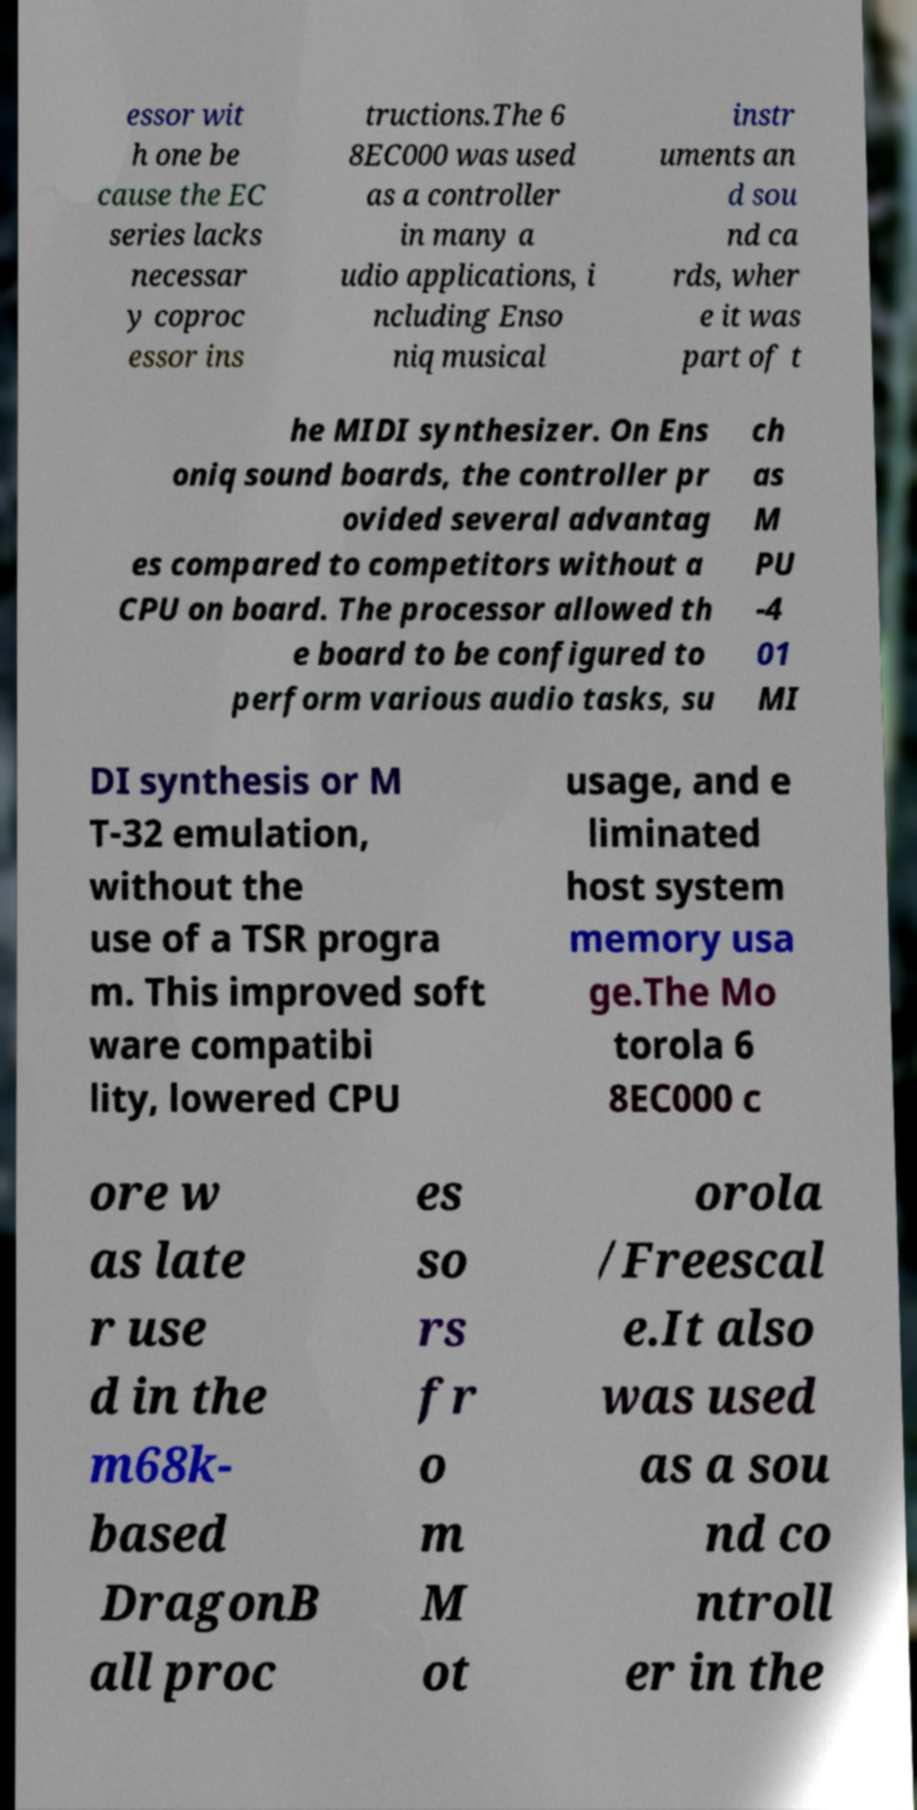Please identify and transcribe the text found in this image. essor wit h one be cause the EC series lacks necessar y coproc essor ins tructions.The 6 8EC000 was used as a controller in many a udio applications, i ncluding Enso niq musical instr uments an d sou nd ca rds, wher e it was part of t he MIDI synthesizer. On Ens oniq sound boards, the controller pr ovided several advantag es compared to competitors without a CPU on board. The processor allowed th e board to be configured to perform various audio tasks, su ch as M PU -4 01 MI DI synthesis or M T-32 emulation, without the use of a TSR progra m. This improved soft ware compatibi lity, lowered CPU usage, and e liminated host system memory usa ge.The Mo torola 6 8EC000 c ore w as late r use d in the m68k- based DragonB all proc es so rs fr o m M ot orola /Freescal e.It also was used as a sou nd co ntroll er in the 